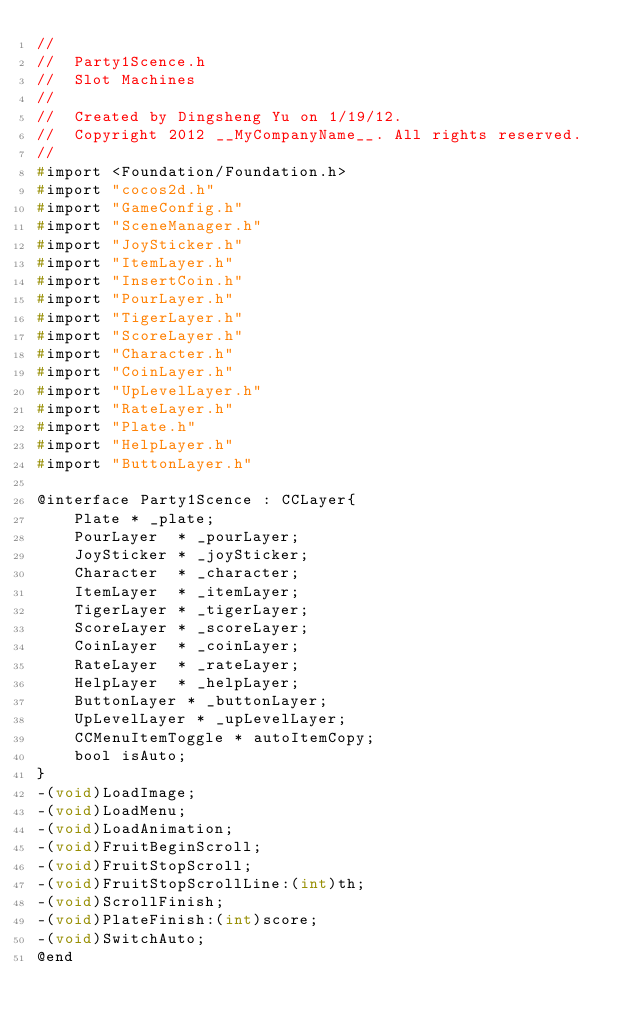<code> <loc_0><loc_0><loc_500><loc_500><_C_>//
//  Party1Scence.h
//  Slot Machines
//
//  Created by Dingsheng Yu on 1/19/12.
//  Copyright 2012 __MyCompanyName__. All rights reserved.
//
#import <Foundation/Foundation.h>
#import "cocos2d.h"
#import "GameConfig.h"
#import "SceneManager.h"
#import "JoySticker.h"
#import "ItemLayer.h"
#import "InsertCoin.h"
#import "PourLayer.h"
#import "TigerLayer.h"
#import "ScoreLayer.h"
#import "Character.h"
#import "CoinLayer.h"
#import "UpLevelLayer.h"
#import "RateLayer.h"
#import "Plate.h"
#import "HelpLayer.h"
#import "ButtonLayer.h"

@interface Party1Scence : CCLayer{
    Plate * _plate;
    PourLayer  * _pourLayer;
    JoySticker * _joySticker;
    Character  * _character;
    ItemLayer  * _itemLayer;
    TigerLayer * _tigerLayer;
    ScoreLayer * _scoreLayer;
    CoinLayer  * _coinLayer;
    RateLayer  * _rateLayer;
    HelpLayer  * _helpLayer;
    ButtonLayer * _buttonLayer;    
    UpLevelLayer * _upLevelLayer;
    CCMenuItemToggle * autoItemCopy;
    bool isAuto;
}
-(void)LoadImage;
-(void)LoadMenu;
-(void)LoadAnimation;
-(void)FruitBeginScroll;
-(void)FruitStopScroll;
-(void)FruitStopScrollLine:(int)th;
-(void)ScrollFinish;
-(void)PlateFinish:(int)score;
-(void)SwitchAuto;
@end</code> 